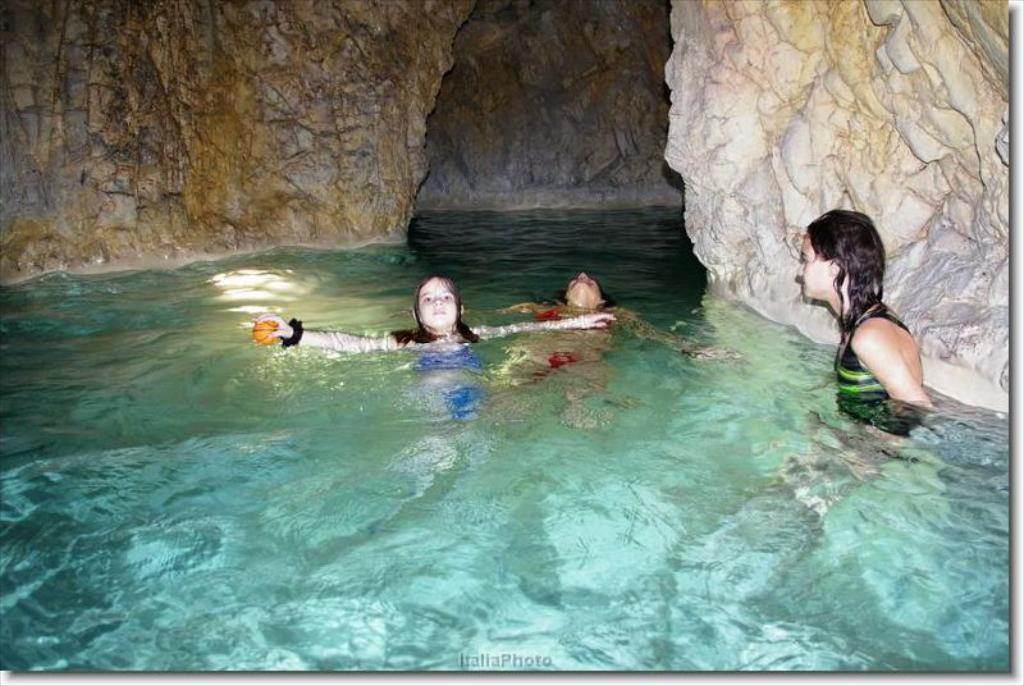What are the persons in the image doing? The persons in the image are in the water. What can be seen in the background of the image? There is a cave in the background of the image. What type of plants can be seen growing on the roof in the image? There are no plants or roof present in the image. Can you see a pig swimming with the persons in the water? There is no pig visible in the image; only persons are present in the water. 